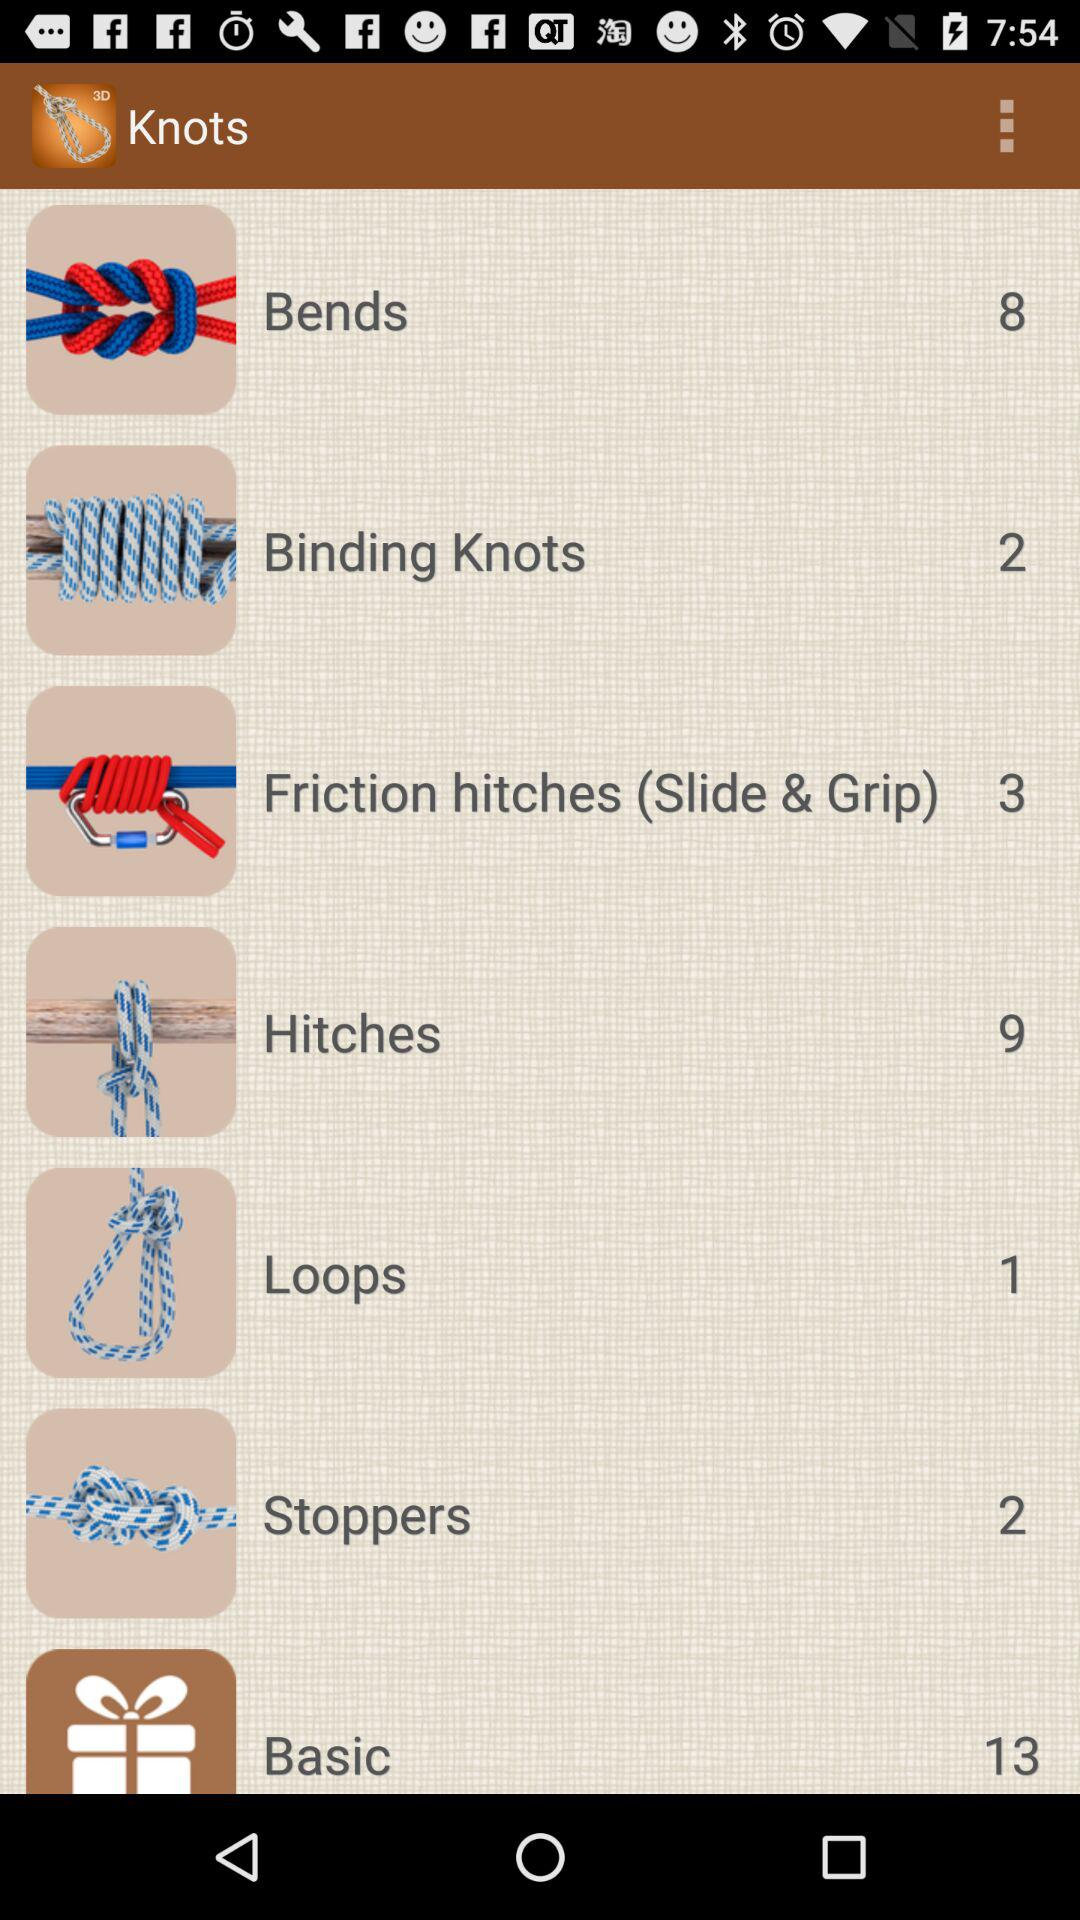How many knots are there in "Loops"? There is 1 knot in "Loops". 